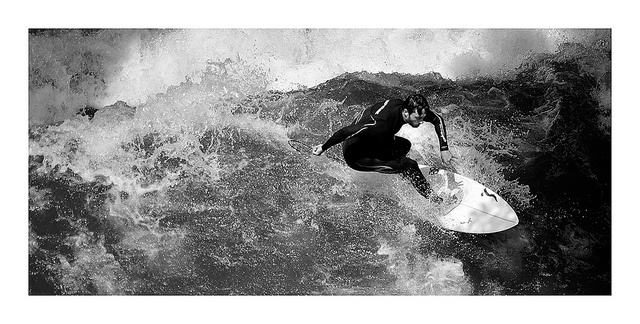Describe the objects in this image and their specific colors. I can see people in white, black, gray, darkgray, and gainsboro tones and surfboard in white, lightgray, darkgray, gray, and black tones in this image. 